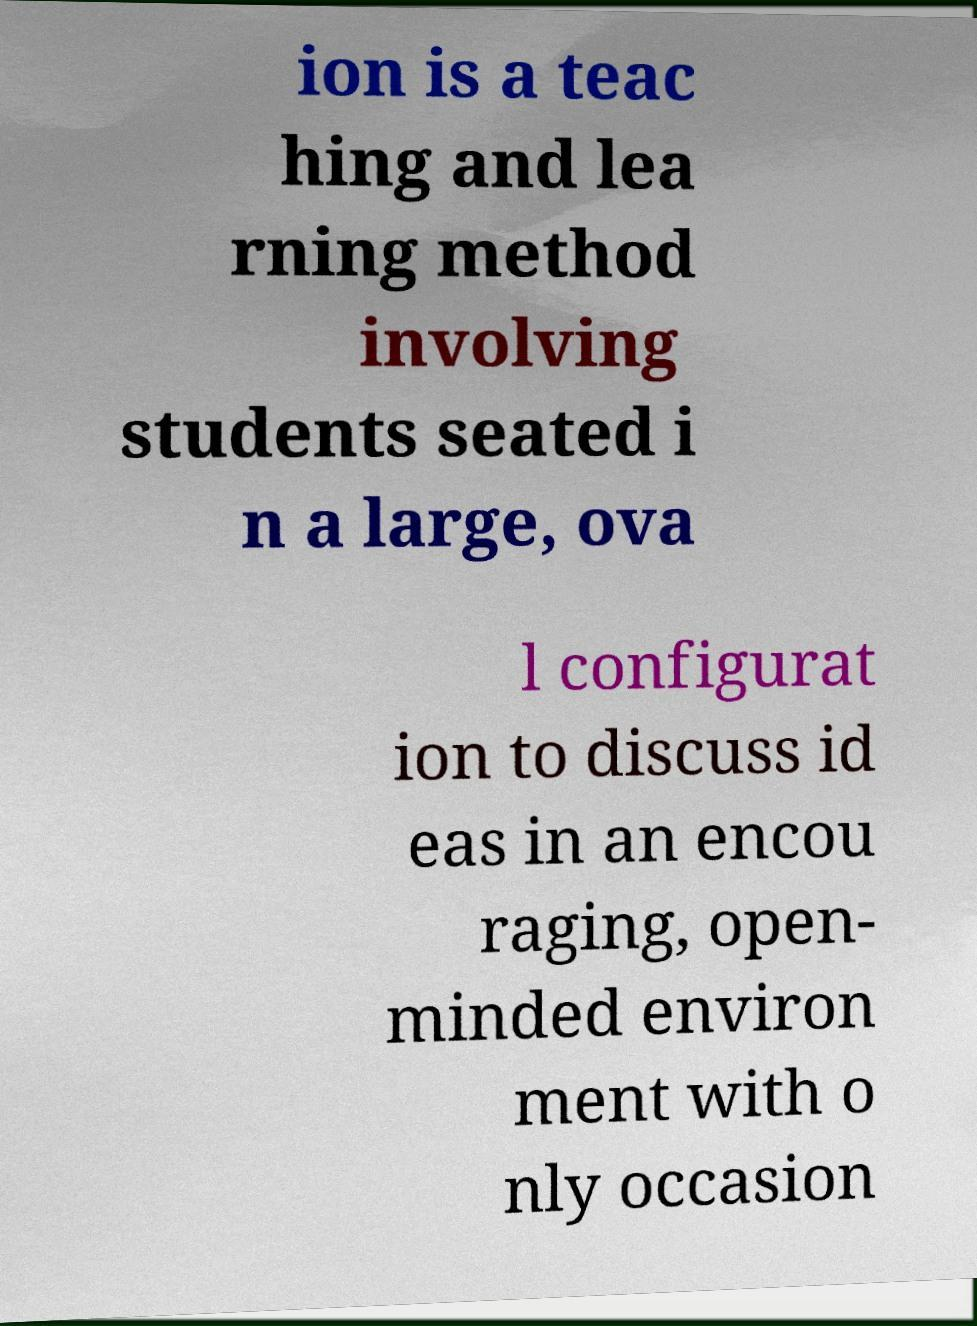Please read and relay the text visible in this image. What does it say? ion is a teac hing and lea rning method involving students seated i n a large, ova l configurat ion to discuss id eas in an encou raging, open- minded environ ment with o nly occasion 